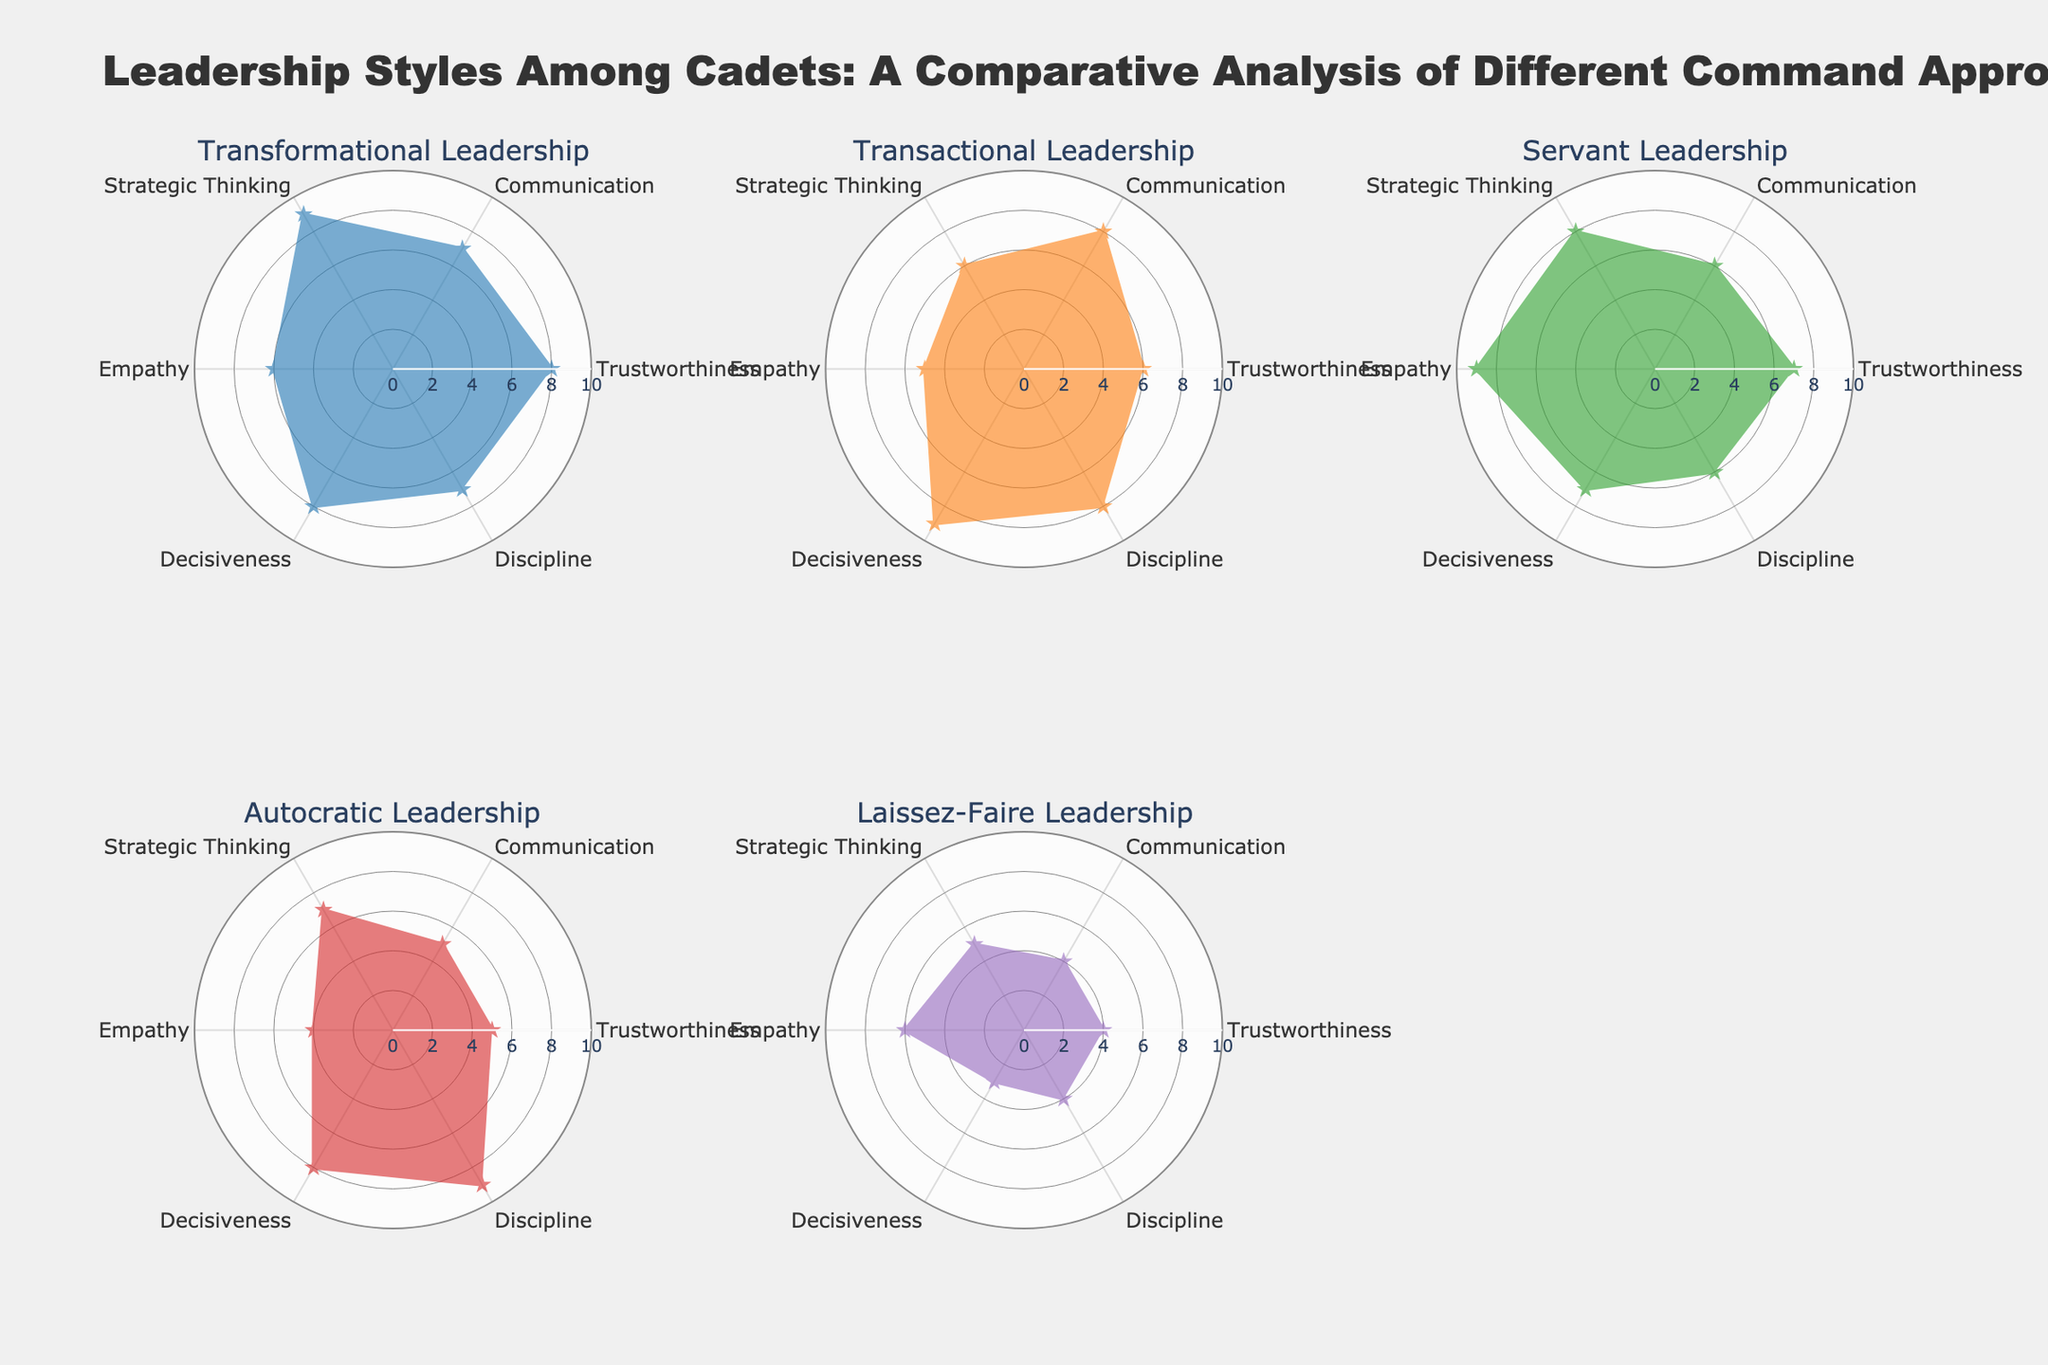Which leadership style has the highest value in Trustworthiness? Look at the "Transformational Leadership" subplot and check the radial value of Trustworthiness, which is the highest among all styles with a value of 8.
Answer: Transformational Leadership How does the Communication rating of Autocratic Leadership compare to that of Transactional Leadership? Compare the radial values of Communication in the subplots for Autocratic Leadership and Transactional Leadership. Autocratic Leadership has a Communication rating of 5, while Transactional Leadership's rating is 8, meaning Autocratic Leadership is lower.
Answer: Autocratic Leadership is lower What is the combined score of Empathy for all the leadership styles? Sum the Empathy values for each leadership style: Transformational (6), Transactional (5), Servant (9), Autocratic (4), and Laissez-Faire (6). The sum is 6 + 5 + 9 + 4 + 6 = 30.
Answer: 30 Which leadership style has the most balanced values across all traits? Balance can be assessed by looking at how close the values are to each other within a leadership style. Servant Leadership shows the most balanced values, ranging mostly between 6 and 8.
Answer: Servant Leadership Is there a leadership style that scores highest in both "Decisiveness" and "Strategic Thinking"? Check the Decisiveness and Strategic Thinking values across all subplots. Transformational Leadership has the highest Strategic Thinking (9) and high Decisiveness (8) but not the highest. Transactional Leadership has the highest Decisiveness (9) but not the highest Strategic Thinking (6). Thus, no single style scores highest in both.
Answer: No What is the average Discipline rating across all leadership styles? Sum the Discipline ratings and divide by the number of leadership styles: (7 + 8 + 6 + 9 + 4) / 5. This equates to (34) / 5 = 6.8.
Answer: 6.8 Which leadership style exhibits the least Empathy? Compare the radial values for Empathy in the subplots. Autocratic Leadership has the lowest value at 4.
Answer: Autocratic Leadership What is the difference in Strategic Thinking between Transformational and Servant Leadership? Look for Strategic Thinking values for both styles. Transformational Leadership has a value of 9, and Servant Leadership has 8. The difference is 9 - 8 = 1.
Answer: 1 How do Laissez-Faire and Autocratic Leadership compare in terms of Trustworthiness? Compare the Trustworthiness values on the figures for both leadership styles. Autocratic Leadership scores 5, while Laissez-Faire scores 4. Autocratic Leadership is higher than Laissez-Faire.
Answer: Autocratic Leadership is higher Which leadership style demonstrates the highest level of Decisiveness? Look at the value for Decisiveness for each subplot. Transactional Leadership exhibits the highest level of Decisiveness with a value of 9.
Answer: Transactional Leadership 